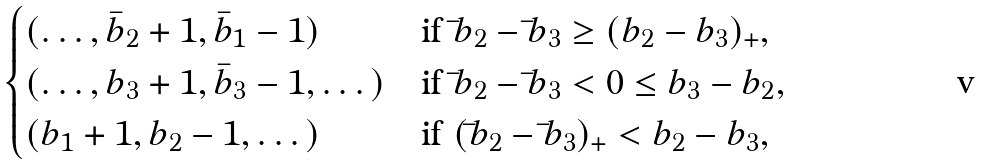<formula> <loc_0><loc_0><loc_500><loc_500>\begin{cases} ( \dots , { \bar { b } } _ { 2 } + 1 , { \bar { b } } _ { 1 } - 1 ) & \text {if ${\bar{ }b}_{2} -{\bar{ }b}_{3} \geq (b_{2} -b_{3})_{+}$} , \\ ( \dots , b _ { 3 } + 1 , { \bar { b } } _ { 3 } - 1 , \dots ) & \text {if ${\bar{ }b}_{2} -{\bar{ }b}_{3} <0\leq b_{3} -b_{2}$} , \\ ( b _ { 1 } + 1 , b _ { 2 } - 1 , \dots ) & \text {if $({\bar{ }b}_{2} -{\bar{ }b}_{3})_{+} <b_{2} -b_{3}$} , \end{cases}</formula> 